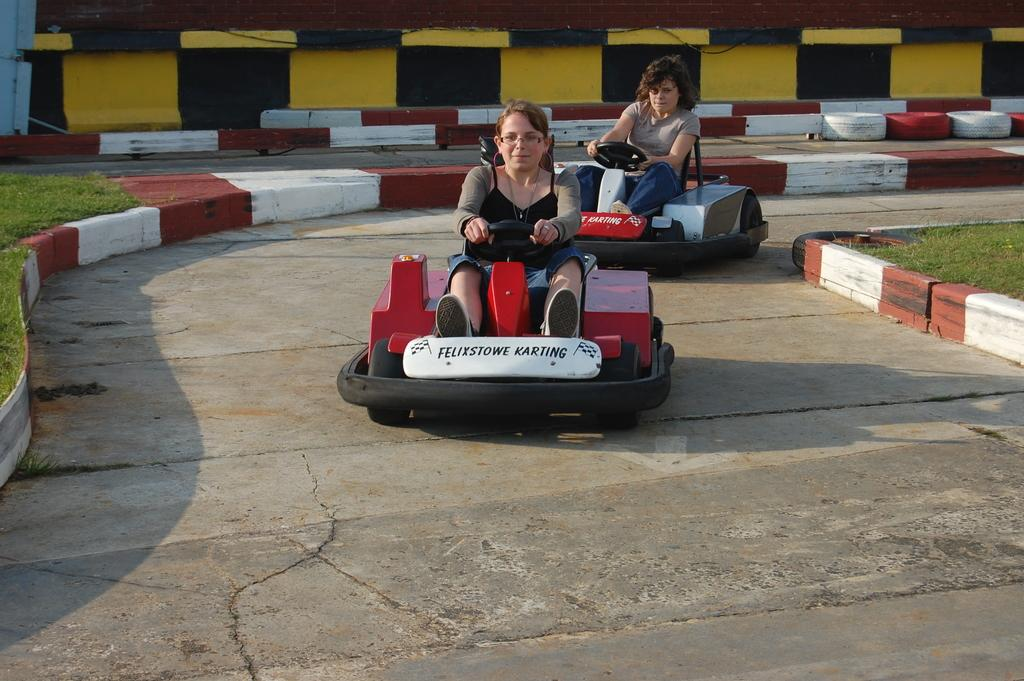How many people are in the image? There are two persons in the image. What are the persons doing in the image? The persons are sitting on go kart cars. What can be seen in the background of the image? There are tires and grass in the background of the image. Can you see a knot tied in the grass in the image? There is no knot visible in the grass in the image. Are there any passengers in the go kart cars in the image? The question is unclear, as the persons sitting on the go kart cars are not referred to as passengers in the provided facts. However, based on the context, it can be inferred that the persons sitting on the go kart cars are the drivers, not passengers. 